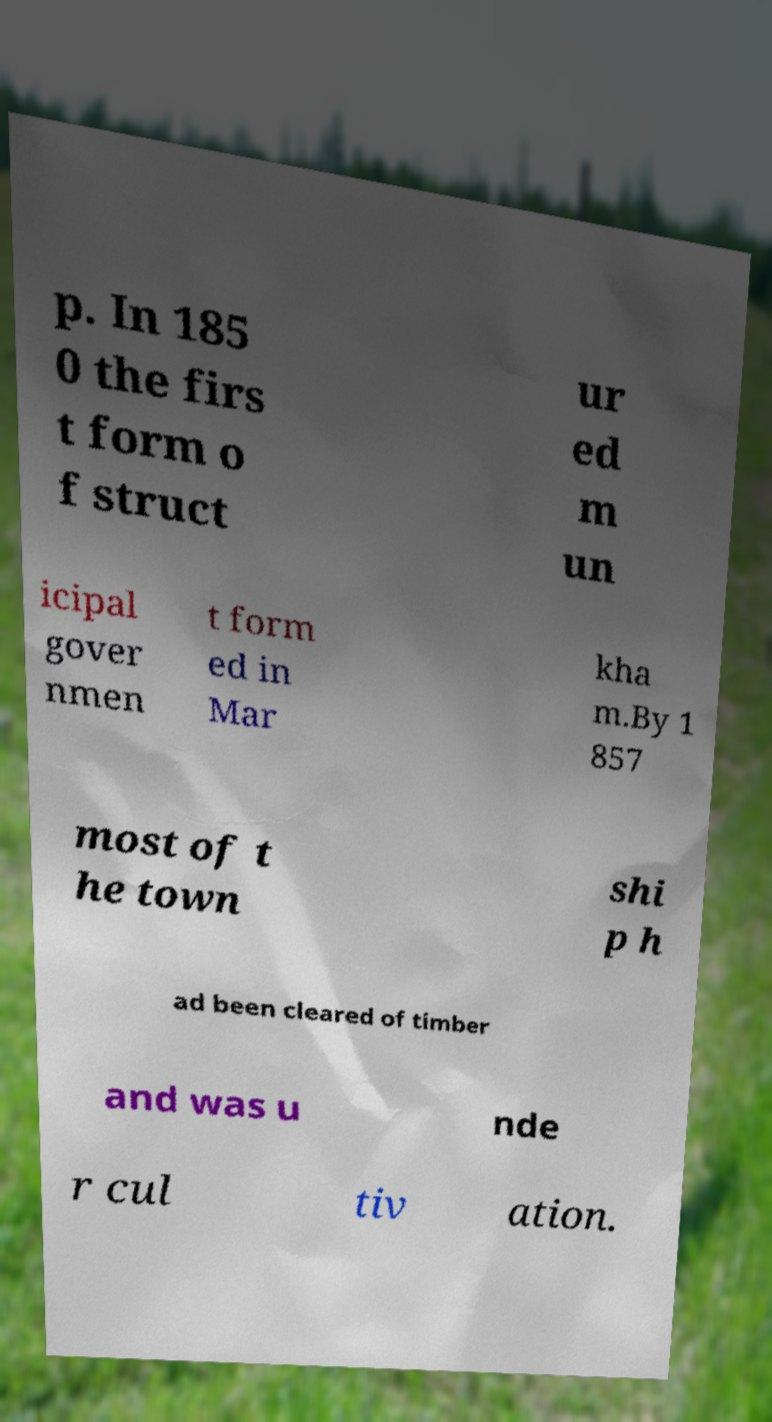Could you extract and type out the text from this image? p. In 185 0 the firs t form o f struct ur ed m un icipal gover nmen t form ed in Mar kha m.By 1 857 most of t he town shi p h ad been cleared of timber and was u nde r cul tiv ation. 